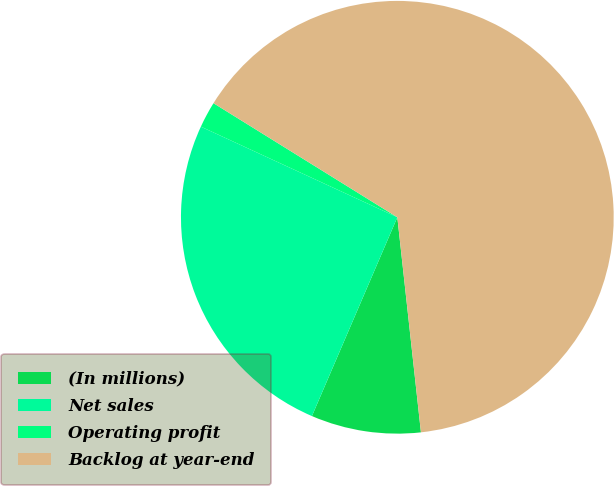Convert chart to OTSL. <chart><loc_0><loc_0><loc_500><loc_500><pie_chart><fcel>(In millions)<fcel>Net sales<fcel>Operating profit<fcel>Backlog at year-end<nl><fcel>8.2%<fcel>25.42%<fcel>1.96%<fcel>64.42%<nl></chart> 